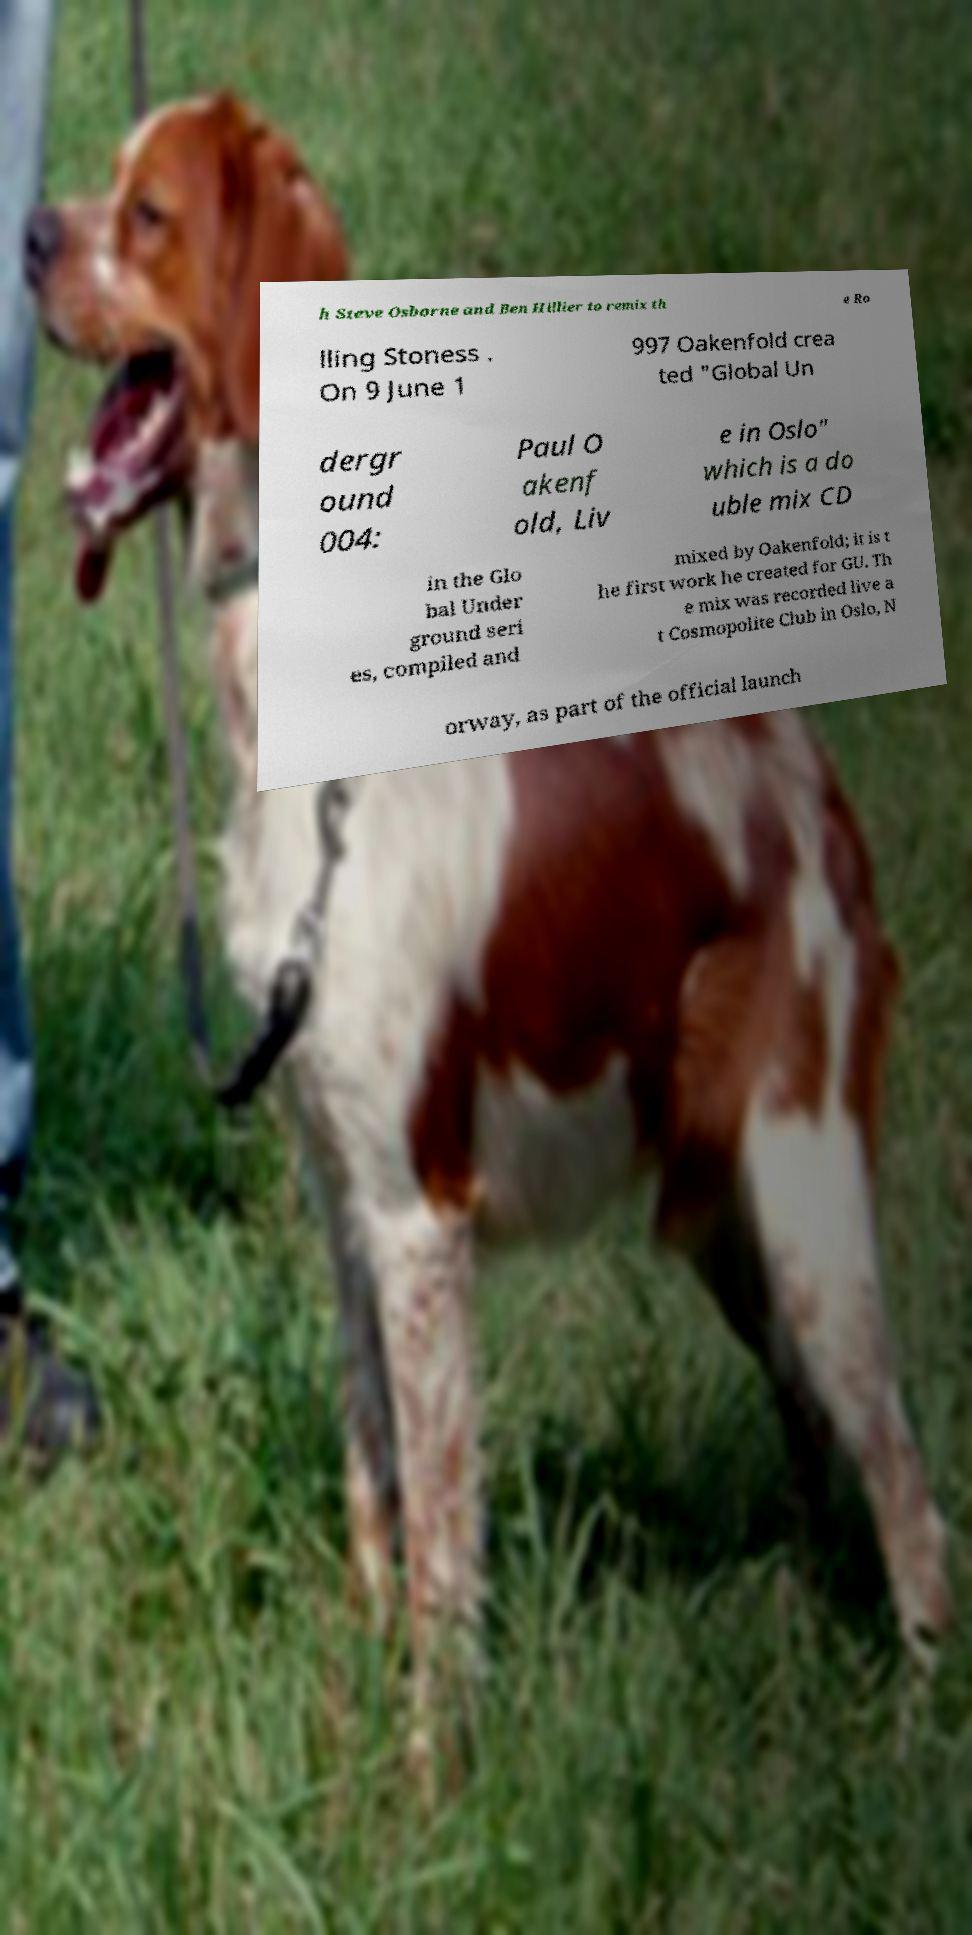Please identify and transcribe the text found in this image. h Steve Osborne and Ben Hillier to remix th e Ro lling Stoness . On 9 June 1 997 Oakenfold crea ted "Global Un dergr ound 004: Paul O akenf old, Liv e in Oslo" which is a do uble mix CD in the Glo bal Under ground seri es, compiled and mixed by Oakenfold; it is t he first work he created for GU. Th e mix was recorded live a t Cosmopolite Club in Oslo, N orway, as part of the official launch 